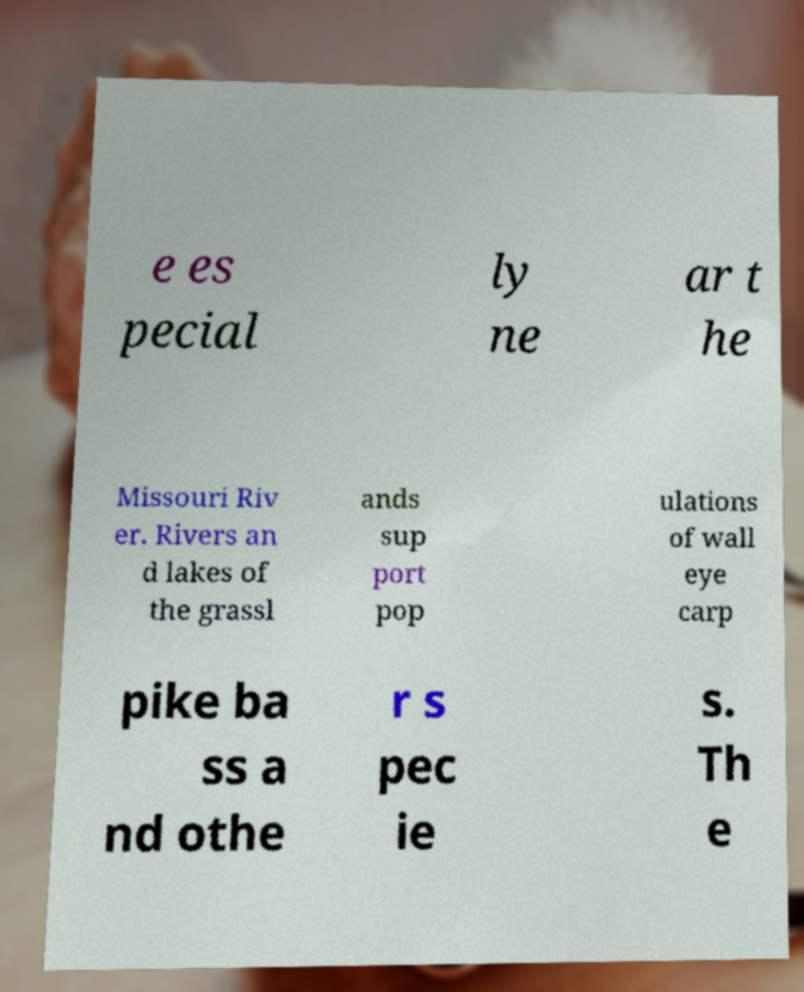There's text embedded in this image that I need extracted. Can you transcribe it verbatim? e es pecial ly ne ar t he Missouri Riv er. Rivers an d lakes of the grassl ands sup port pop ulations of wall eye carp pike ba ss a nd othe r s pec ie s. Th e 